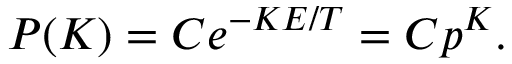Convert formula to latex. <formula><loc_0><loc_0><loc_500><loc_500>\, P ( K ) = C e ^ { - K E / T } = C p ^ { K } .</formula> 